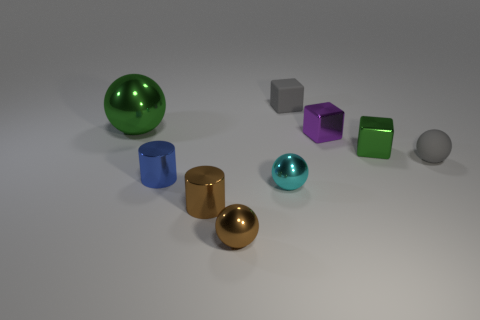There is a blue cylinder left of the tiny ball that is in front of the cyan sphere; how big is it?
Offer a very short reply. Small. Are there fewer blue metallic things on the left side of the tiny blue thing than cyan metal objects?
Make the answer very short. Yes. Do the large thing and the rubber cube have the same color?
Give a very brief answer. No. What is the size of the brown cylinder?
Keep it short and to the point. Small. How many metallic cubes are the same color as the large sphere?
Provide a succinct answer. 1. There is a green metallic thing that is to the right of the gray thing behind the large object; is there a tiny purple block behind it?
Your response must be concise. Yes. The green thing that is the same size as the cyan metal thing is what shape?
Your answer should be compact. Cube. What number of tiny things are gray matte balls or gray matte things?
Your answer should be very brief. 2. There is a large thing that is the same material as the cyan sphere; what is its color?
Your answer should be compact. Green. There is a gray object in front of the matte block; does it have the same shape as the green shiny thing on the left side of the cyan shiny sphere?
Offer a very short reply. Yes. 